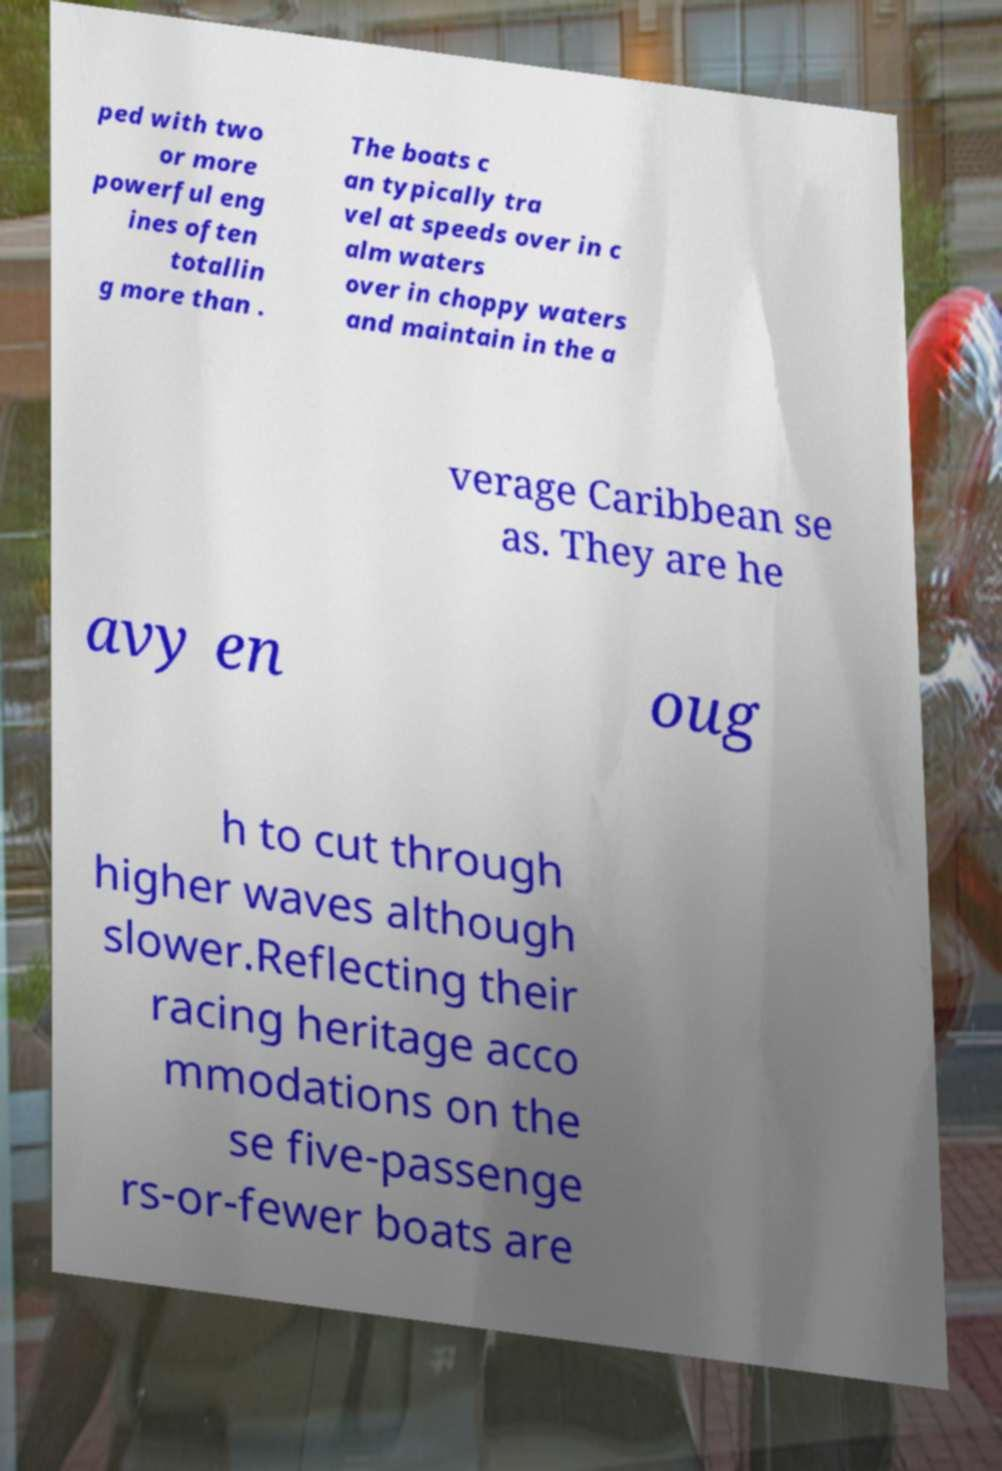Could you extract and type out the text from this image? ped with two or more powerful eng ines often totallin g more than . The boats c an typically tra vel at speeds over in c alm waters over in choppy waters and maintain in the a verage Caribbean se as. They are he avy en oug h to cut through higher waves although slower.Reflecting their racing heritage acco mmodations on the se five-passenge rs-or-fewer boats are 